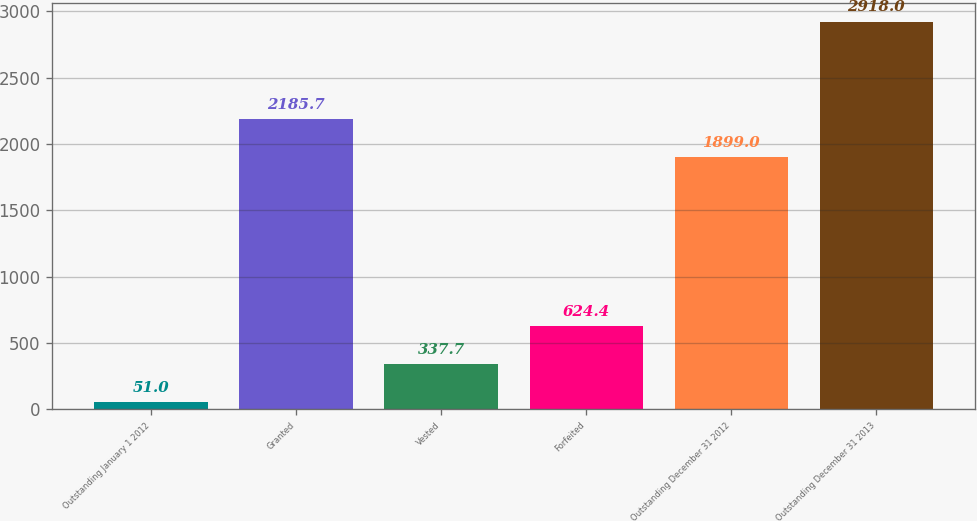Convert chart. <chart><loc_0><loc_0><loc_500><loc_500><bar_chart><fcel>Outstanding January 1 2012<fcel>Granted<fcel>Vested<fcel>Forfeited<fcel>Outstanding December 31 2012<fcel>Outstanding December 31 2013<nl><fcel>51<fcel>2185.7<fcel>337.7<fcel>624.4<fcel>1899<fcel>2918<nl></chart> 